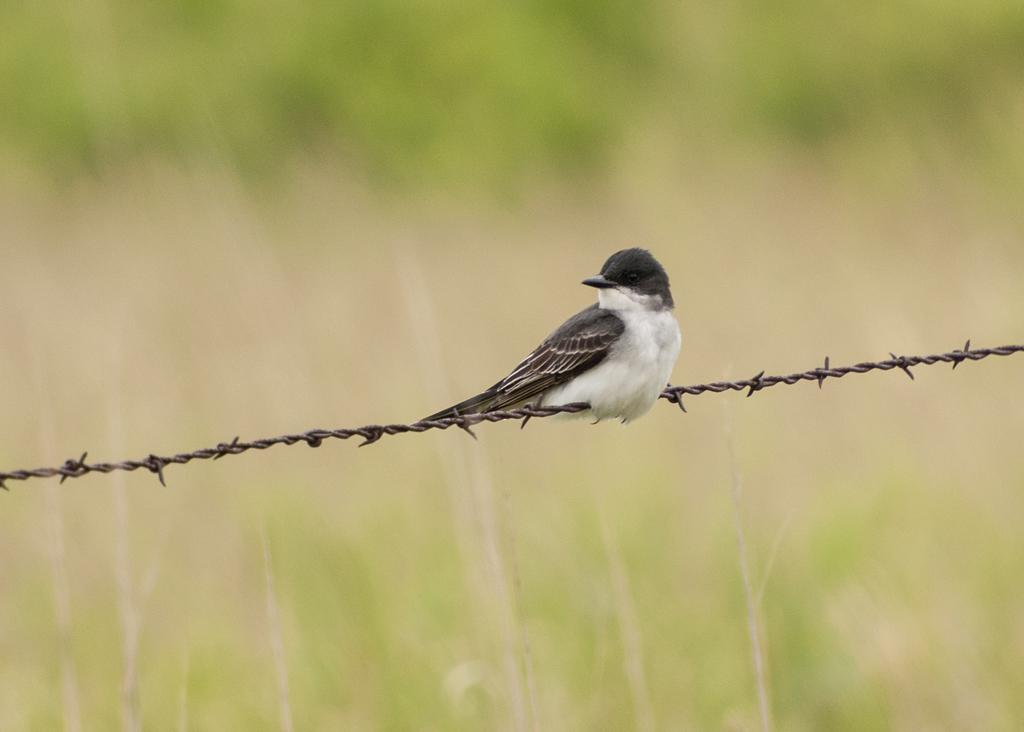What type of animal can be seen in the picture? There is a bird in the picture. Where is the bird located in the image? The bird is on a metal wire. What type of vegetation is visible at the top and bottom of the picture? The top and bottom of the picture appear to have green grass. How does the bird look in the picture? The bird's appearance cannot be determined from the question, as it is not asking about a specific detail about the bird. However, we can describe the bird's location, which is on a metal wire. 